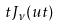<formula> <loc_0><loc_0><loc_500><loc_500>t J _ { \nu } ( u t )</formula> 